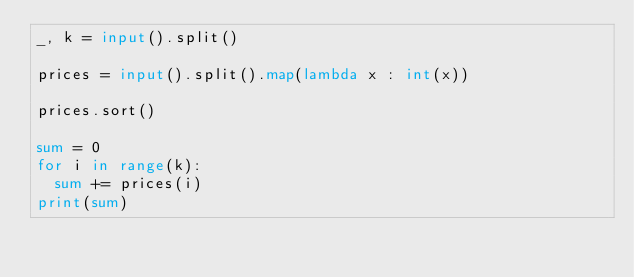Convert code to text. <code><loc_0><loc_0><loc_500><loc_500><_Python_>_, k = input().split()

prices = input().split().map(lambda x : int(x))

prices.sort()

sum = 0
for i in range(k):
	sum += prices(i)
print(sum)</code> 